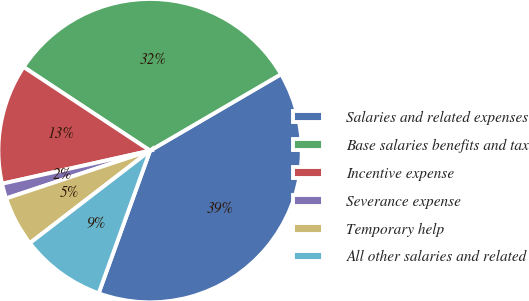<chart> <loc_0><loc_0><loc_500><loc_500><pie_chart><fcel>Salaries and related expenses<fcel>Base salaries benefits and tax<fcel>Incentive expense<fcel>Severance expense<fcel>Temporary help<fcel>All other salaries and related<nl><fcel>38.92%<fcel>32.29%<fcel>12.8%<fcel>1.6%<fcel>5.33%<fcel>9.06%<nl></chart> 